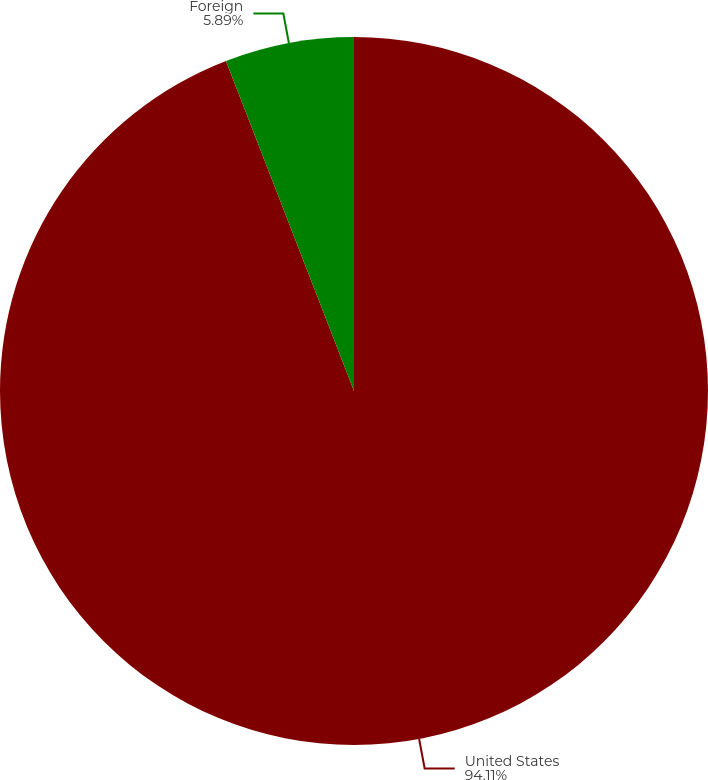Convert chart to OTSL. <chart><loc_0><loc_0><loc_500><loc_500><pie_chart><fcel>United States<fcel>Foreign<nl><fcel>94.11%<fcel>5.89%<nl></chart> 